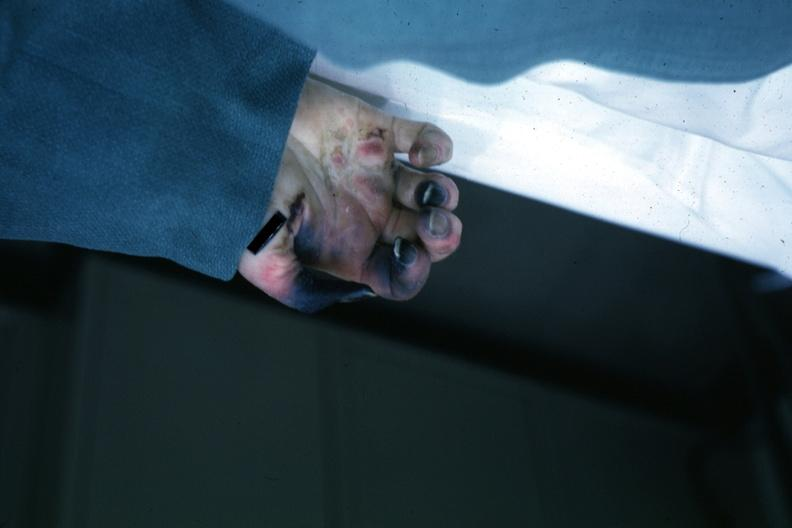what does this image show?
Answer the question using a single word or phrase. Obvious gangrenous necrosis due to shock or embolism postoperative cardiac surgery 